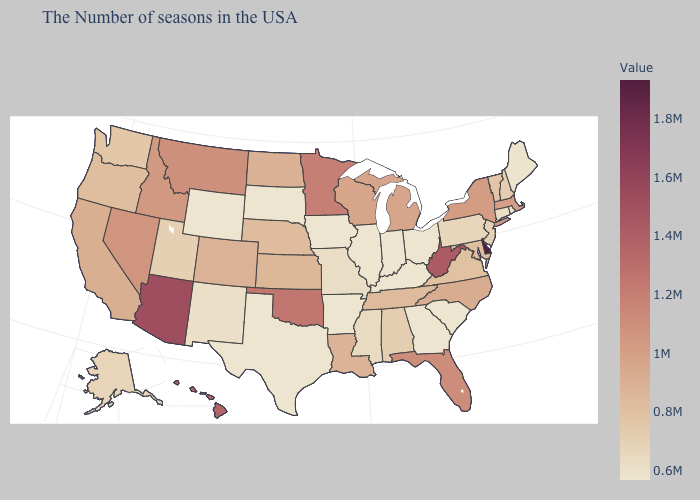Among the states that border Arkansas , does Mississippi have the highest value?
Concise answer only. No. Among the states that border Rhode Island , which have the highest value?
Write a very short answer. Massachusetts. Which states have the highest value in the USA?
Short answer required. Delaware. Among the states that border Massachusetts , does Vermont have the highest value?
Answer briefly. No. Among the states that border Florida , does Georgia have the lowest value?
Quick response, please. Yes. 